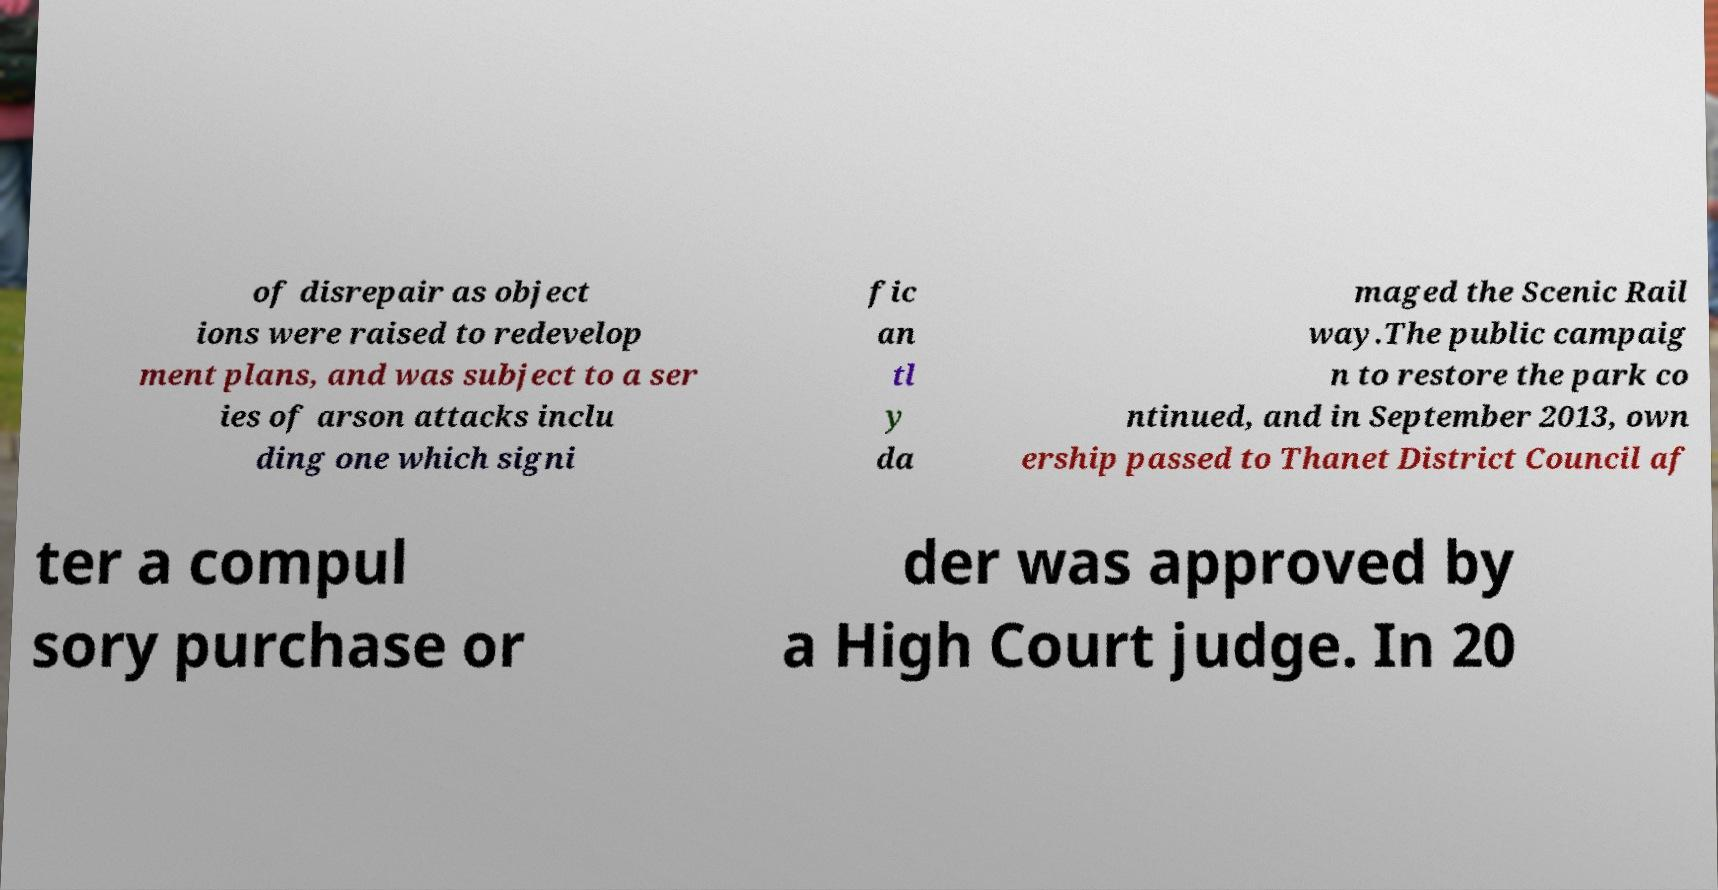There's text embedded in this image that I need extracted. Can you transcribe it verbatim? of disrepair as object ions were raised to redevelop ment plans, and was subject to a ser ies of arson attacks inclu ding one which signi fic an tl y da maged the Scenic Rail way.The public campaig n to restore the park co ntinued, and in September 2013, own ership passed to Thanet District Council af ter a compul sory purchase or der was approved by a High Court judge. In 20 